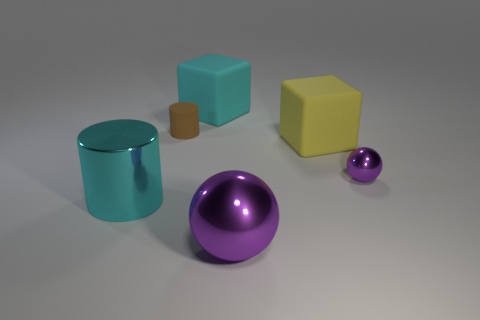Can you describe the shapes and colors of the objects in the image? Certainly! The image showcases a collection of geometric shapes. From left to right, there is a shiny teal cylinder, a smaller brown rectangular box, a larger aqua-blue cube, a prominent purple sphere, and finally, a small purple sphere. The presence of these objects in solid colors and simple shapes might suggest a study in geometry or an exercise in 3D modeling. 